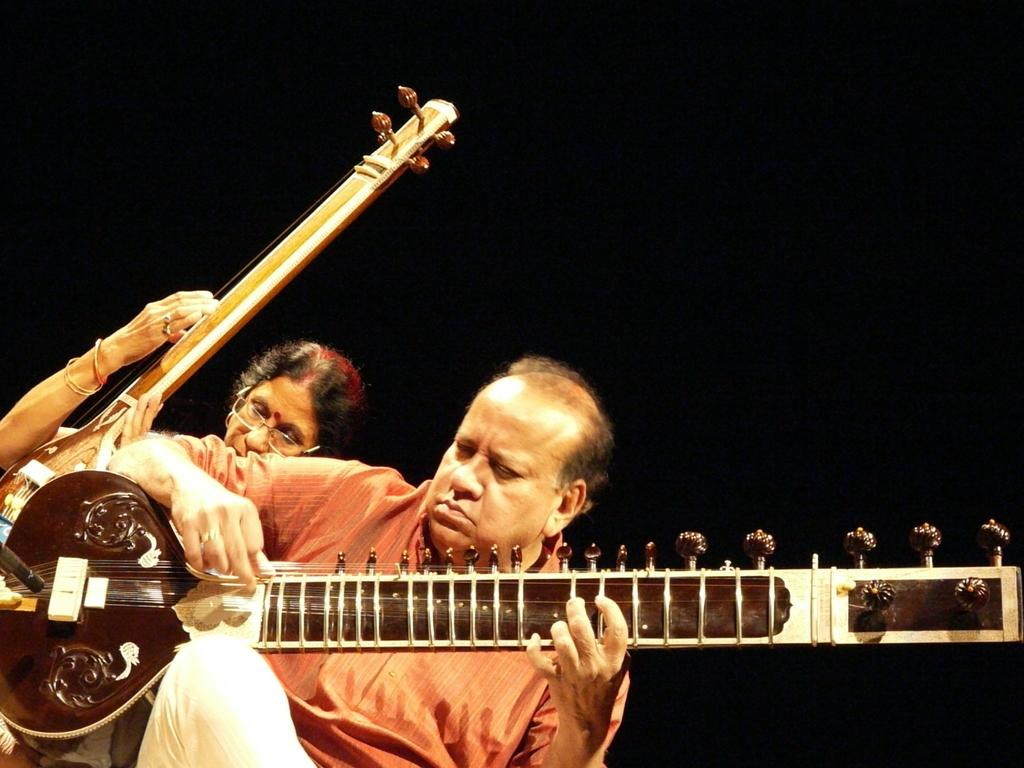What is the man in the image wearing? The man is wearing a red shirt and white pants. What is the man doing in the image? The man is playing an Indian guitar. Is there anyone else in the image besides the man? Yes, there is a woman in the image. What is the woman wearing in the image? The woman is wearing specs. What is the woman doing in the image? The woman is also playing an Indian guitar. How many clocks can be seen in the image? There are no clocks visible in the image. What is the cause of death for the man and woman in the image? There is no indication of death in the image; both the man and woman are playing Indian guitars. 